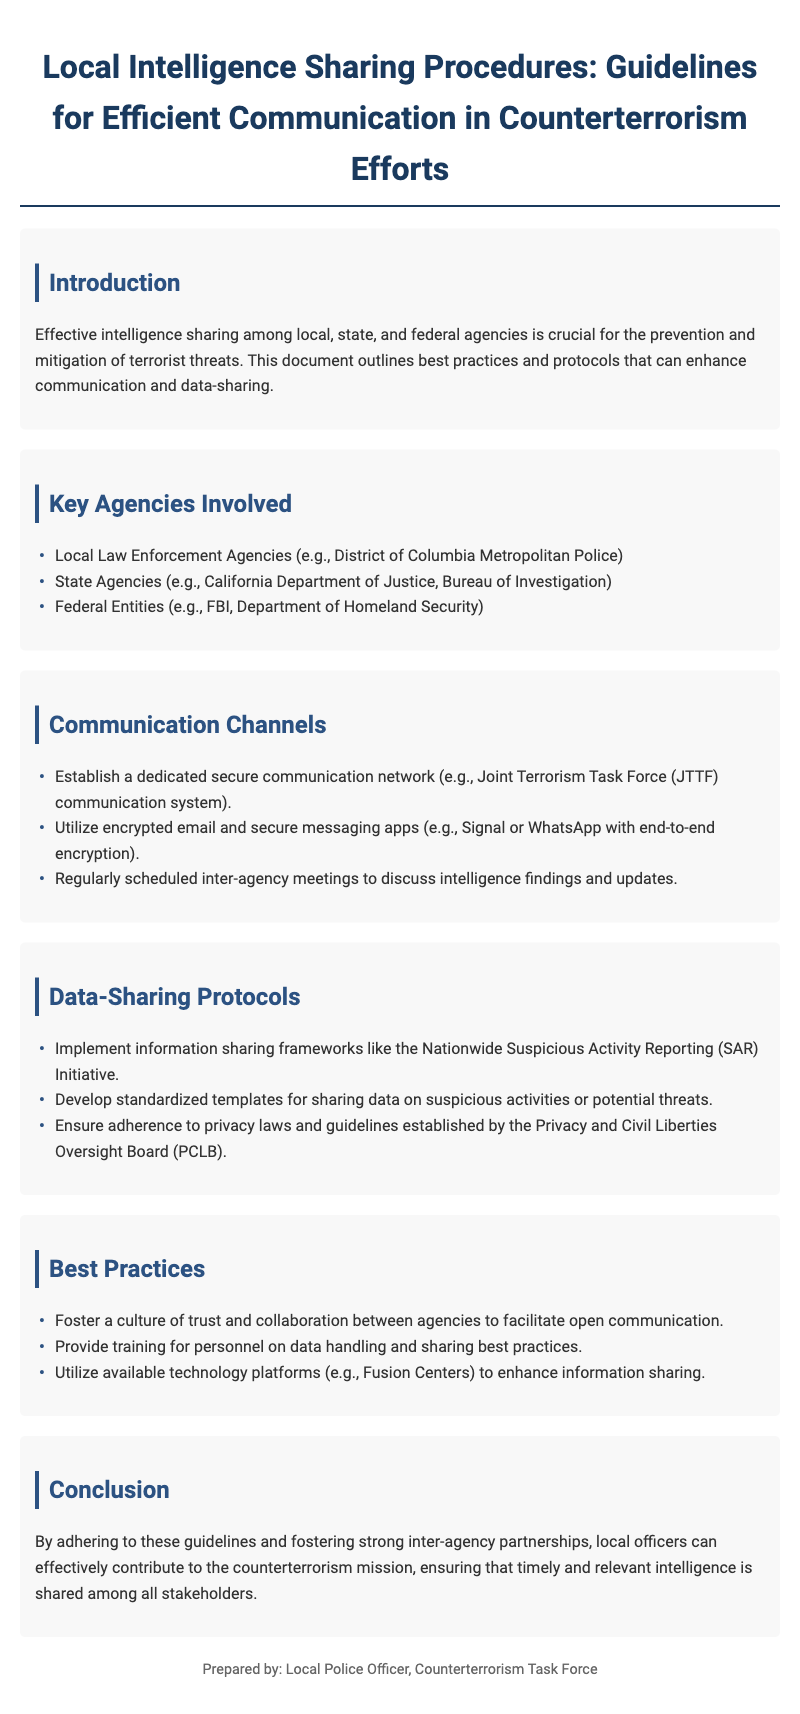What is the title of the document? The title is stated prominently at the top of the document, which reflects its content and purpose.
Answer: Local Intelligence Sharing Procedures: Guidelines for Efficient Communication in Counterterrorism Efforts What is a key agency involved in counterterrorism? This information is found in the section listing the various agencies involved in such efforts.
Answer: FBI What type of communication network is recommended? The document describes specific communication methods in the context of counterterrorism efforts.
Answer: Joint Terrorism Task Force (JTTF) communication system What is one protocol mentioned for data sharing? This information can be found in the section discussing best practices for data-sharing among agencies.
Answer: Nationwide Suspicious Activity Reporting (SAR) Initiative How many best practices are listed in the document? The number of points listed in the best practices section is relevant to understanding the document's content.
Answer: Three 